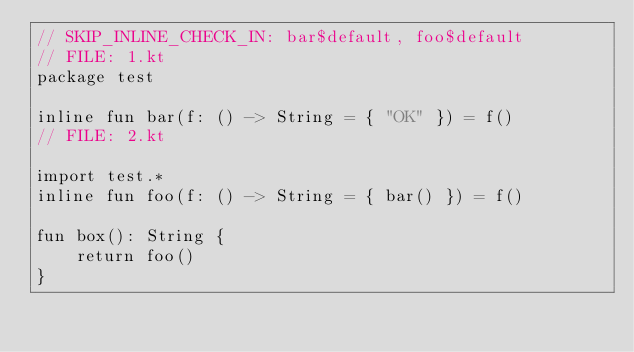Convert code to text. <code><loc_0><loc_0><loc_500><loc_500><_Kotlin_>// SKIP_INLINE_CHECK_IN: bar$default, foo$default
// FILE: 1.kt
package test

inline fun bar(f: () -> String = { "OK" }) = f()
// FILE: 2.kt

import test.*
inline fun foo(f: () -> String = { bar() }) = f()

fun box(): String {
    return foo()
}
</code> 